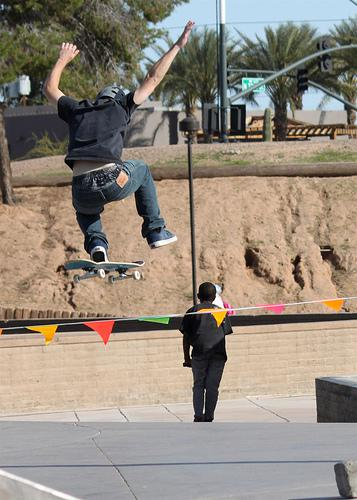Question: what is the nearest man doing?
Choices:
A. Skipping.
B. Running.
C. Walking.
D. Jumping.
Answer with the letter. Answer: D Question: where are the men?
Choices:
A. Shopping mall.
B. Beach.
C. Skate park.
D. Basketball court.
Answer with the letter. Answer: C Question: who is highest?
Choices:
A. Furthest man.
B. Nearest woman.
C. Furthest wpman.
D. Nearest man.
Answer with the letter. Answer: D Question: when was this taken?
Choices:
A. At night.
B. In the afternoon.
C. At dawn.
D. During the day.
Answer with the letter. Answer: D Question: what is on the nearest man's head?
Choices:
A. A cap.
B. Helmet.
C. A top hat.
D. Sunglasses.
Answer with the letter. Answer: B 